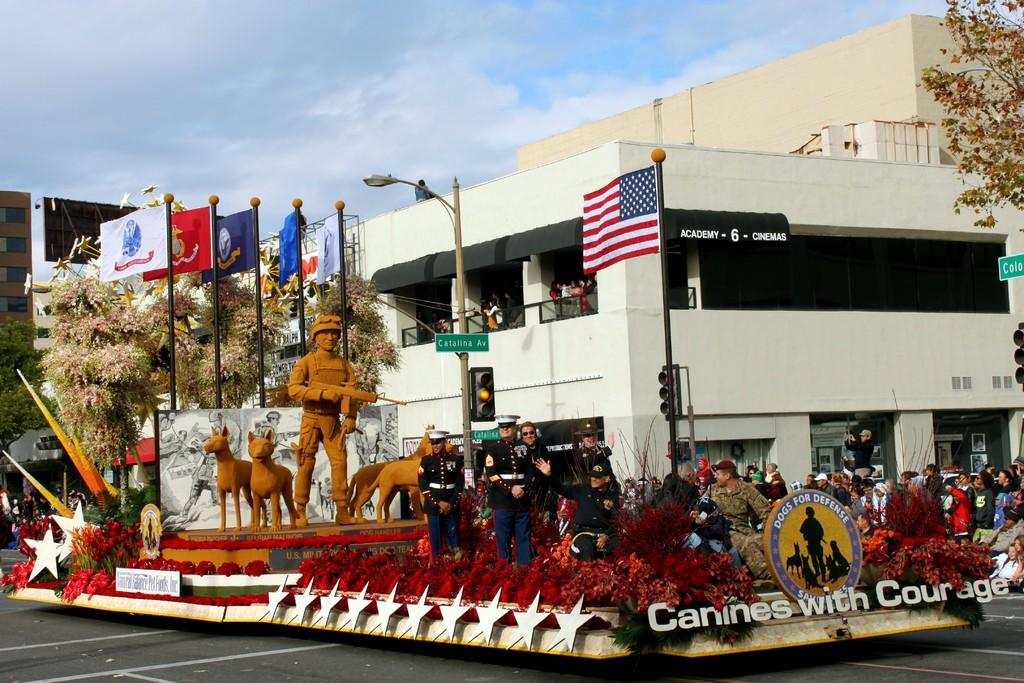Provide a one-sentence caption for the provided image. A float in a parade for Canines with Courage. 